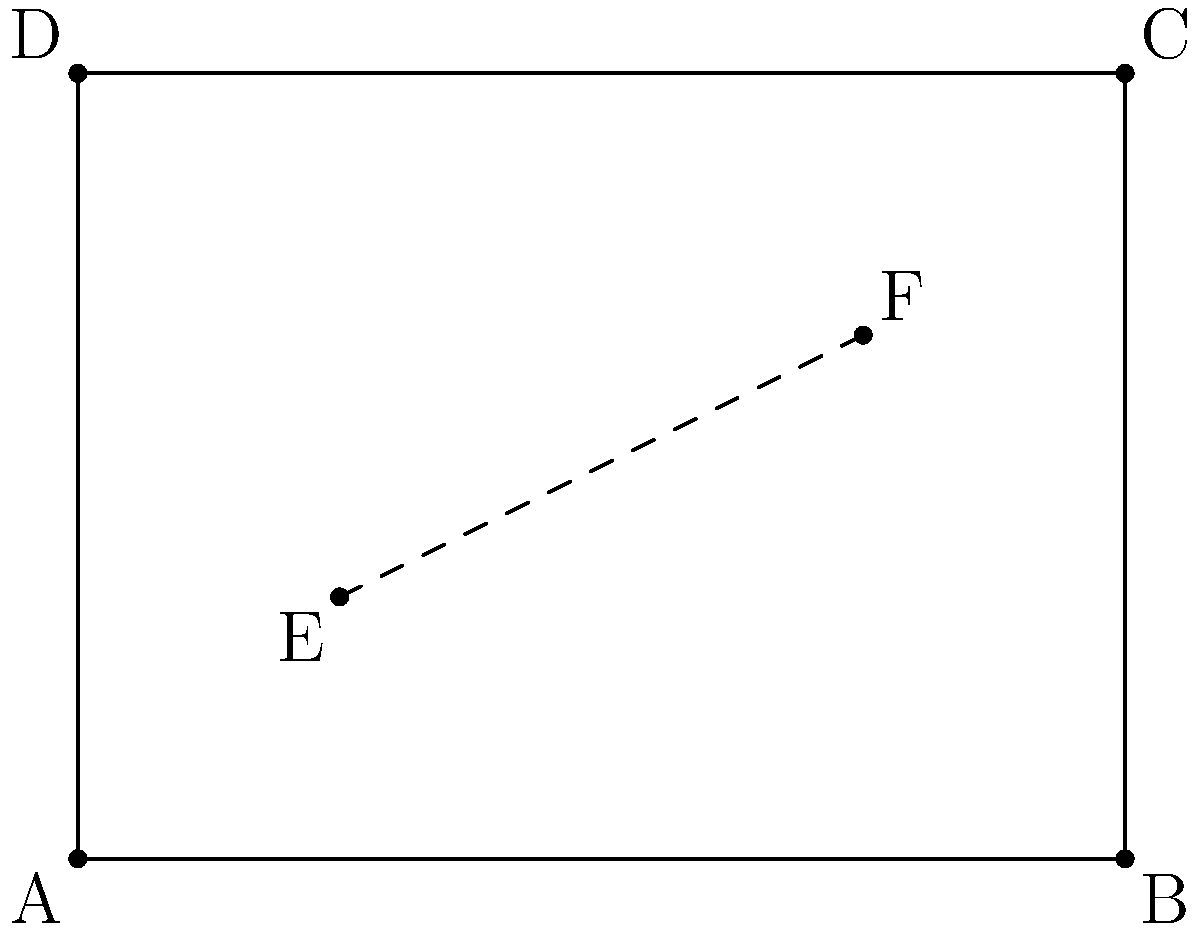In your open-plan office, you need to run a network cable from point E to point F as shown in the floor plan above. The office measures 8 meters by 6 meters, with E located at (2,2) and F at (6,4). What is the shortest possible length of cable needed to connect these two points? Round your answer to two decimal places. To find the shortest path between two points in a plane, we can use the distance formula derived from the Pythagorean theorem. This approach is particularly relevant for an open-plan office layout, where there are no obstacles between points.

Step 1: Identify the coordinates of points E and F.
E: (2,2)
F: (6,4)

Step 2: Calculate the difference in x and y coordinates.
Δx = 6 - 2 = 4
Δy = 4 - 2 = 2

Step 3: Apply the distance formula:
d = $$\sqrt{(\Delta x)^2 + (\Delta y)^2}$$

Step 4: Substitute the values:
d = $$\sqrt{4^2 + 2^2}$$
d = $$\sqrt{16 + 4}$$
d = $$\sqrt{20}$$

Step 5: Simplify:
d = $$2\sqrt{5}$$ ≈ 4.47 meters

Step 6: Round to two decimal places:
d ≈ 4.47 meters

This approach ensures the most efficient use of cabling resources, which is crucial for both cost-effectiveness in corporate settings and optimal network performance - factors that would be appreciated in a marketing manager's role.
Answer: 4.47 meters 